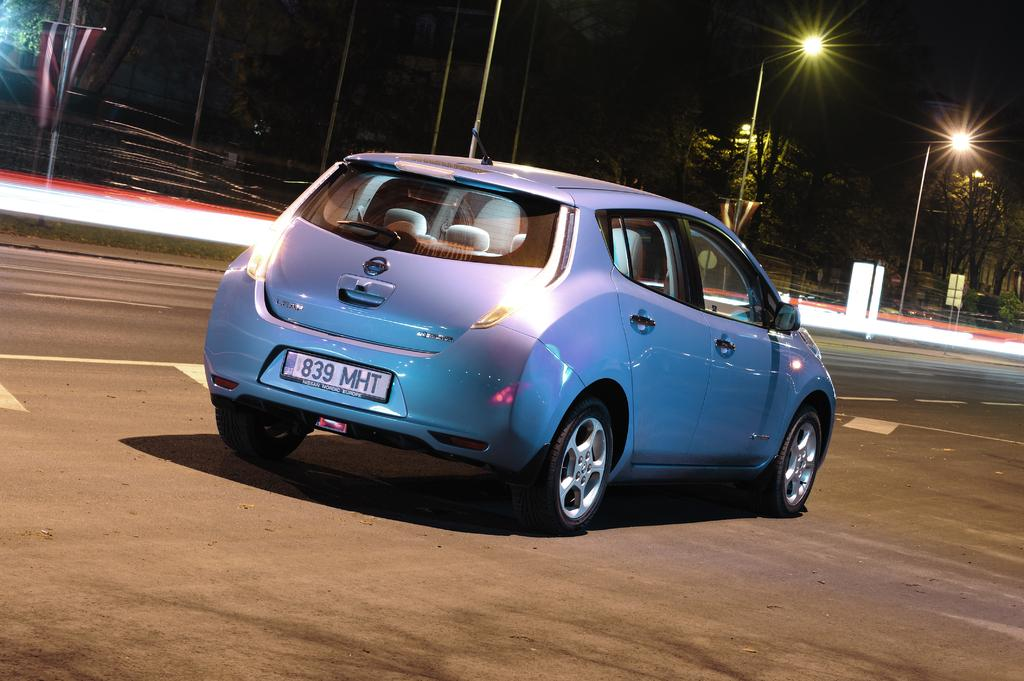What is the main subject of the image? There is a car on the road in the image. What can be seen in the background of the image? In the background of the image, there is a fence, trees, street lights, the sky, and other objects. Can you describe the road in the image? The road is where the car is located, and it is likely a public road. What type of objects are visible in the background? The background objects include a fence, trees, street lights, and other unspecified objects. Can you tell me how many times the car has dropped its keys in the image? There is no indication in the image that the car has dropped its keys, so it cannot be determined from the picture. 